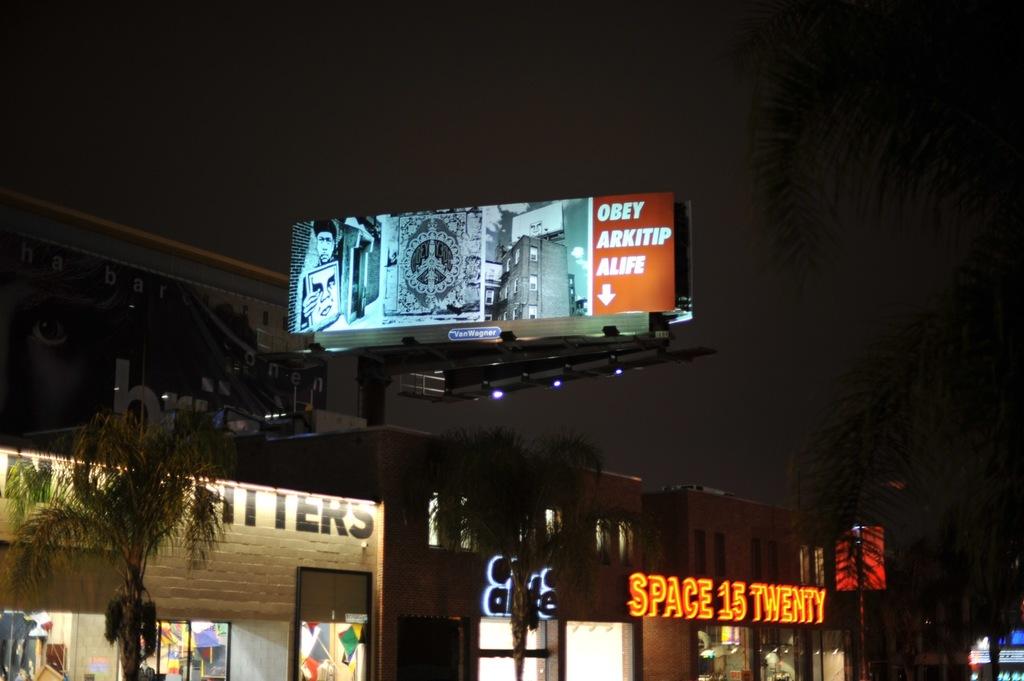What is the name of the building below the large sign?
Give a very brief answer. Space 15 twenty. What does the large sign read?
Provide a succinct answer. Obey arkitip alife. 